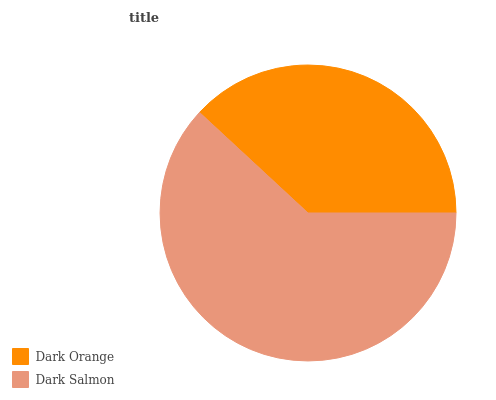Is Dark Orange the minimum?
Answer yes or no. Yes. Is Dark Salmon the maximum?
Answer yes or no. Yes. Is Dark Salmon the minimum?
Answer yes or no. No. Is Dark Salmon greater than Dark Orange?
Answer yes or no. Yes. Is Dark Orange less than Dark Salmon?
Answer yes or no. Yes. Is Dark Orange greater than Dark Salmon?
Answer yes or no. No. Is Dark Salmon less than Dark Orange?
Answer yes or no. No. Is Dark Salmon the high median?
Answer yes or no. Yes. Is Dark Orange the low median?
Answer yes or no. Yes. Is Dark Orange the high median?
Answer yes or no. No. Is Dark Salmon the low median?
Answer yes or no. No. 